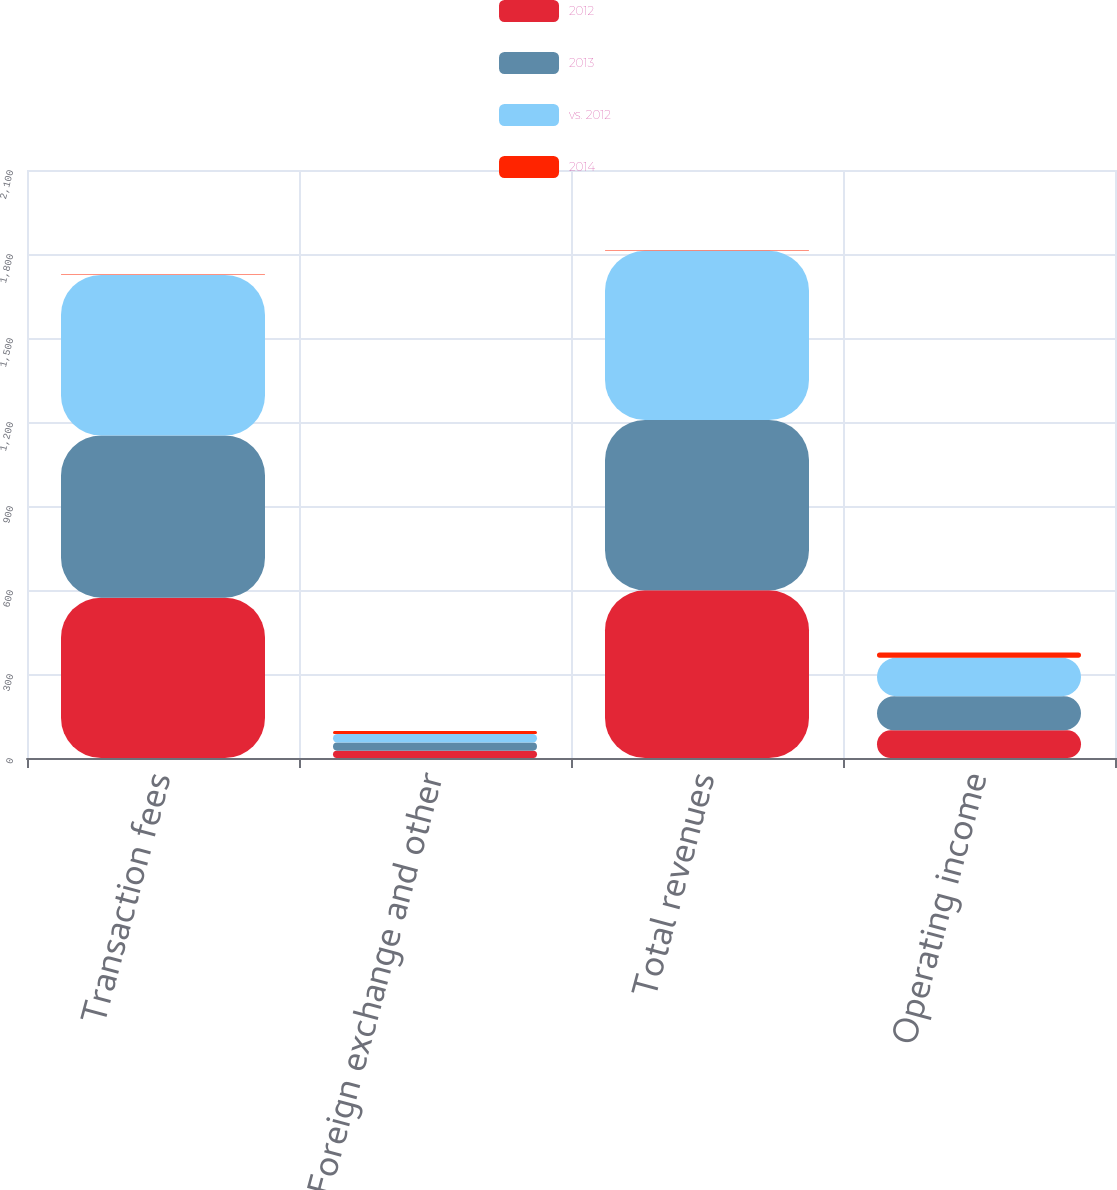<chart> <loc_0><loc_0><loc_500><loc_500><stacked_bar_chart><ecel><fcel>Transaction fees<fcel>Foreign exchange and other<fcel>Total revenues<fcel>Operating income<nl><fcel>2012<fcel>572.7<fcel>26.1<fcel>598.8<fcel>98.7<nl><fcel>2013<fcel>579.1<fcel>29.4<fcel>608.5<fcel>121.9<nl><fcel>vs. 2012<fcel>573.6<fcel>30.3<fcel>603.9<fcel>137.6<nl><fcel>2014<fcel>1<fcel>11<fcel>2<fcel>19<nl></chart> 